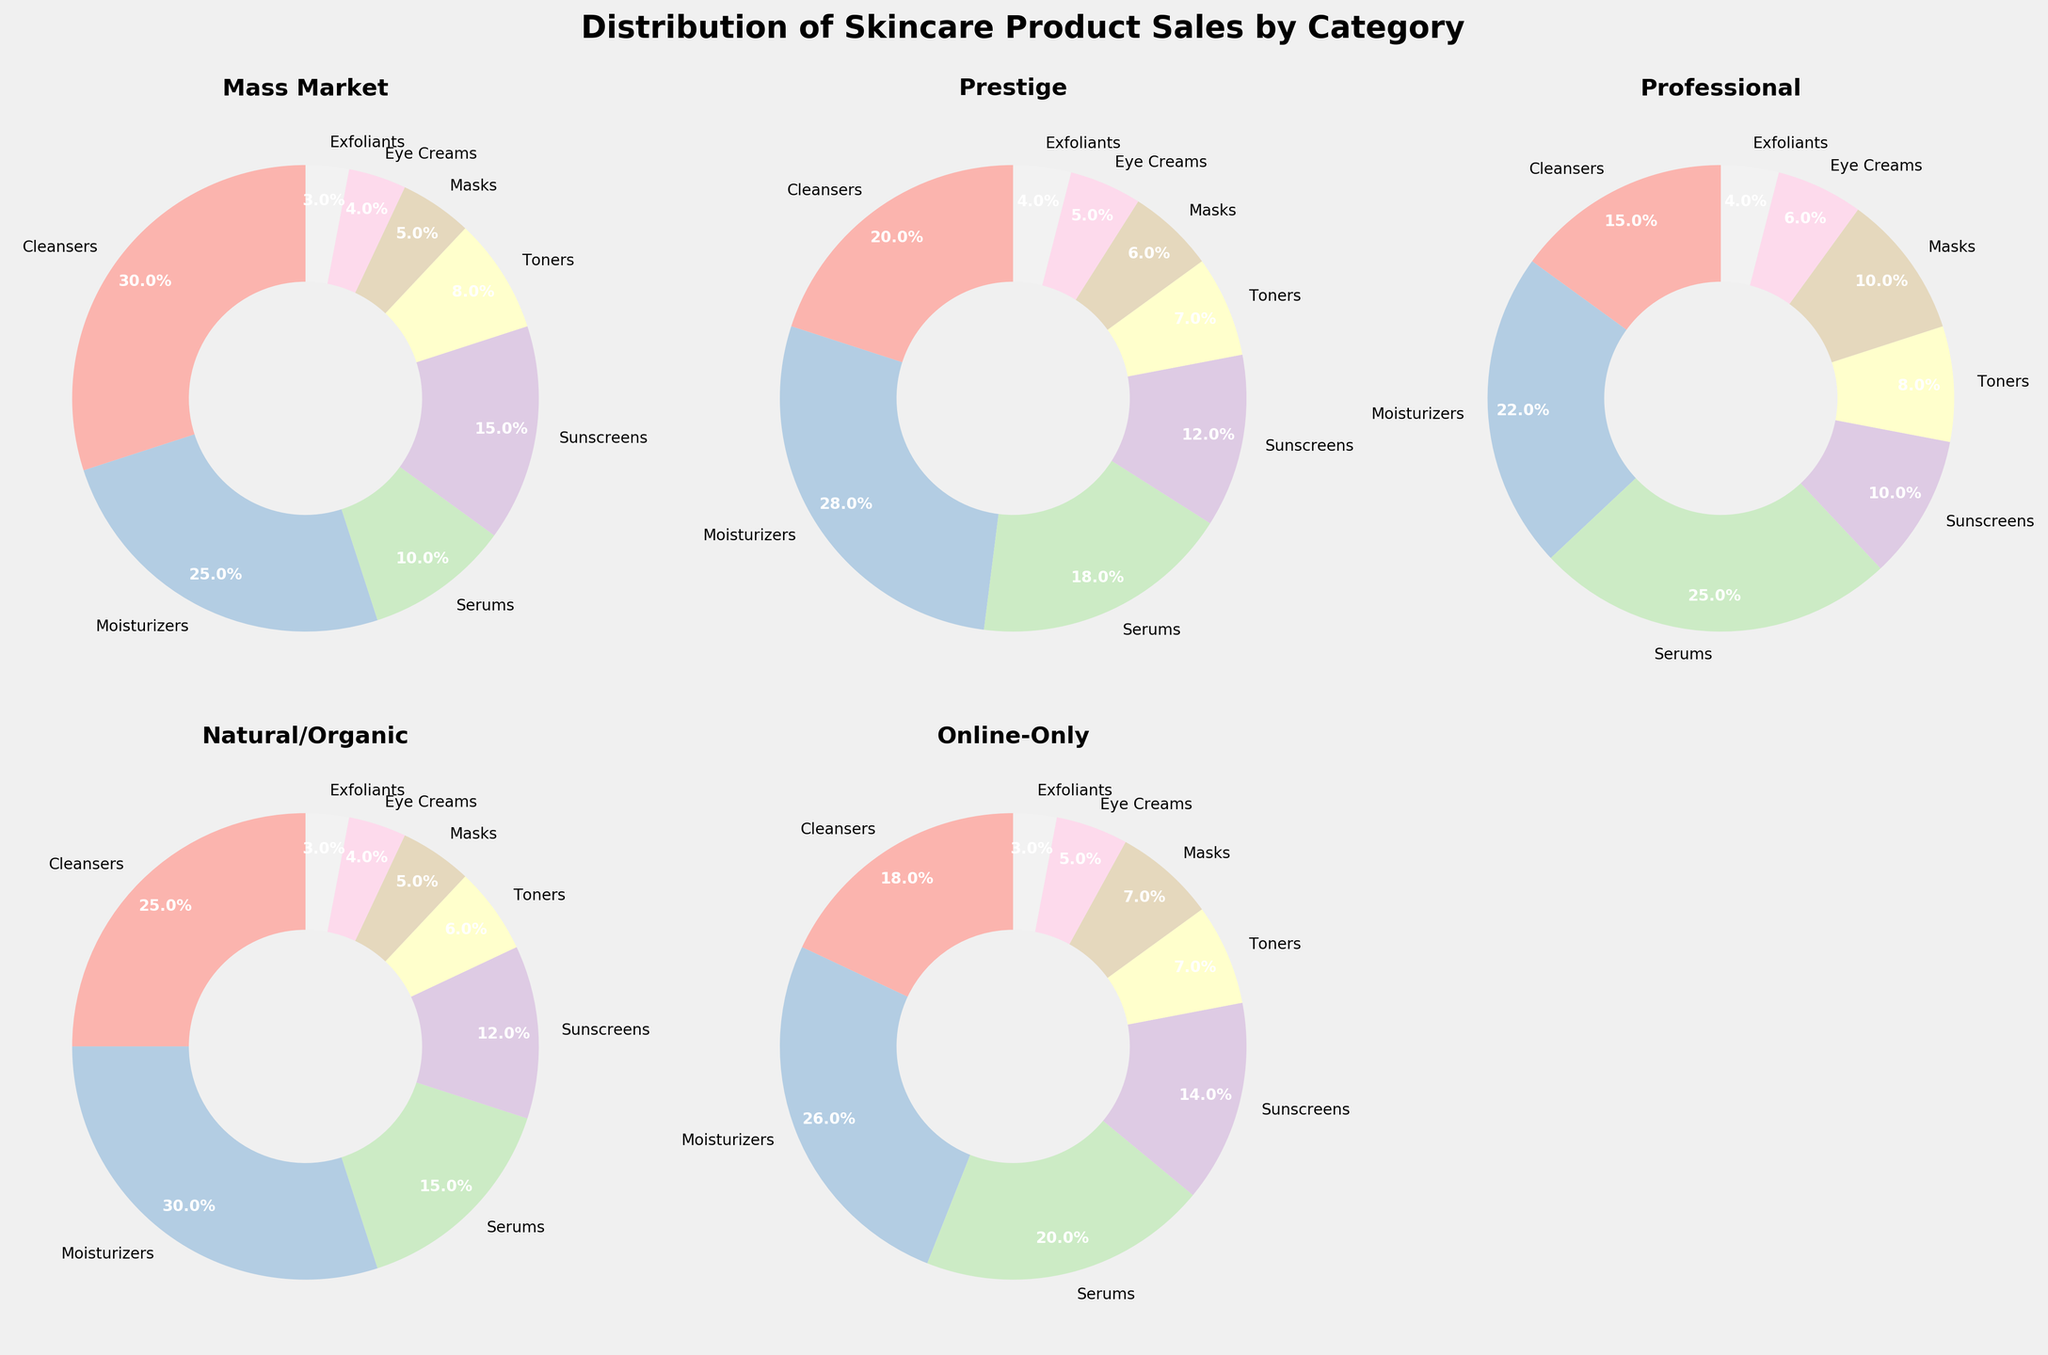What percentage of sales do Serums contribute to the Professional category? First, we locate the Professional category pie chart. From the chart, we see that the Serums section is labeled with the percentage. By cross-referencing the color and label, we find it is 25%.
Answer: 25% Which category has the largest market share in the Online-Only segment? Look at the Online-Only segment pie chart and identify the section with the largest slice. The largest section is clearly marked as Moisturizers.
Answer: Moisturizers Between Mass Market and Prestige, which category sells more Eye Creams? Compare the Eye Creams sections of both the Mass Market and Prestige pie charts. Mass Market segment shows 4% while the Prestige segment shows 5%. Therefore, Prestige sells more Eye Creams.
Answer: Prestige Calculate the total percentage of sales for products other than Cleansers in the Natural/Organic category. In the Natural/Organic category, Cleansers account for 25%. Subtract this percentage from 100% to find the rest: 100% - 25% = 75%.
Answer: 75% Which segment has the smallest share of Exfoliants? Compare the slices labeled as Exfoliants across all segments. The smallest slice is in the Mass Market segment, showing 3%.
Answer: Mass Market How does the share of Toners in the Professional segment compare to the share in the Online-Only segment? Locate the Toners slices in both the Professional and Online-Only pie charts. Professional shows 8% while Online-Only shows 7%. Thus, Professional has a larger share.
Answer: Professional What is the combined percentage of sales for Sunscreens and Masks in the Prestige category? In the Prestige category, Sunscreens account for 12% and Masks account for 6%. Add these percentages: 12% + 6% = 18%.
Answer: 18% Which category has a higher percentage of Cleansers, Mass Market or Natural/Organic? Compare the Cleansers slices in the Mass Market and Natural/Organic categories. Mass Market shows 30% while Natural/Organic shows 25%. Mass Market has a higher percentage.
Answer: Mass Market Determine the difference in percentage between Serums sales in the Prestige and Mass Market segments. First, find the Serums percentages from both segments: Prestige is 18%, Mass Market is 10%. Subtract the smaller from the larger: 18% - 10% = 8%.
Answer: 8% 